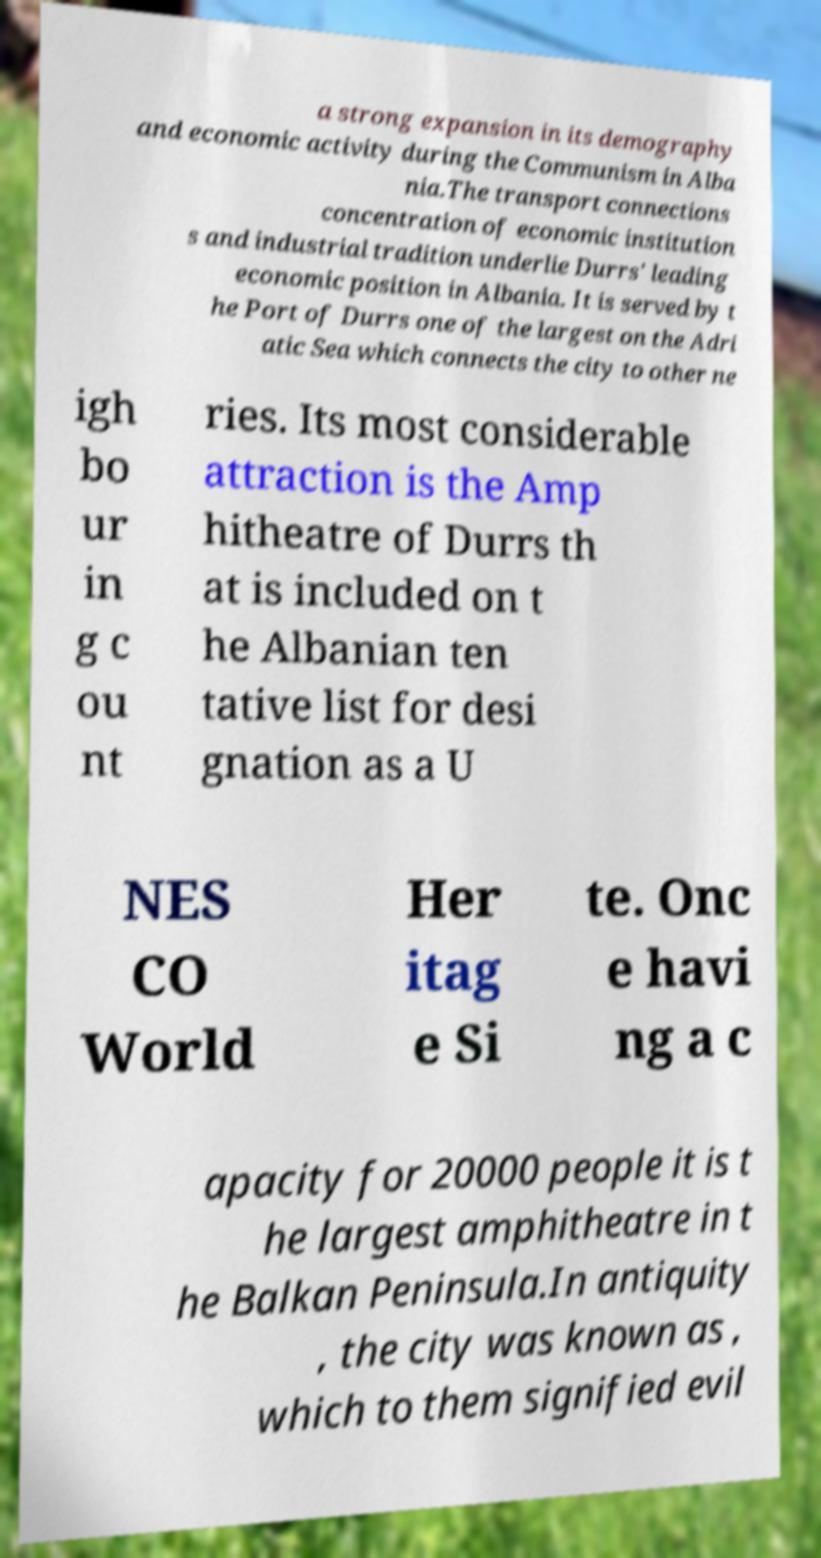Can you accurately transcribe the text from the provided image for me? a strong expansion in its demography and economic activity during the Communism in Alba nia.The transport connections concentration of economic institution s and industrial tradition underlie Durrs' leading economic position in Albania. It is served by t he Port of Durrs one of the largest on the Adri atic Sea which connects the city to other ne igh bo ur in g c ou nt ries. Its most considerable attraction is the Amp hitheatre of Durrs th at is included on t he Albanian ten tative list for desi gnation as a U NES CO World Her itag e Si te. Onc e havi ng a c apacity for 20000 people it is t he largest amphitheatre in t he Balkan Peninsula.In antiquity , the city was known as , which to them signified evil 